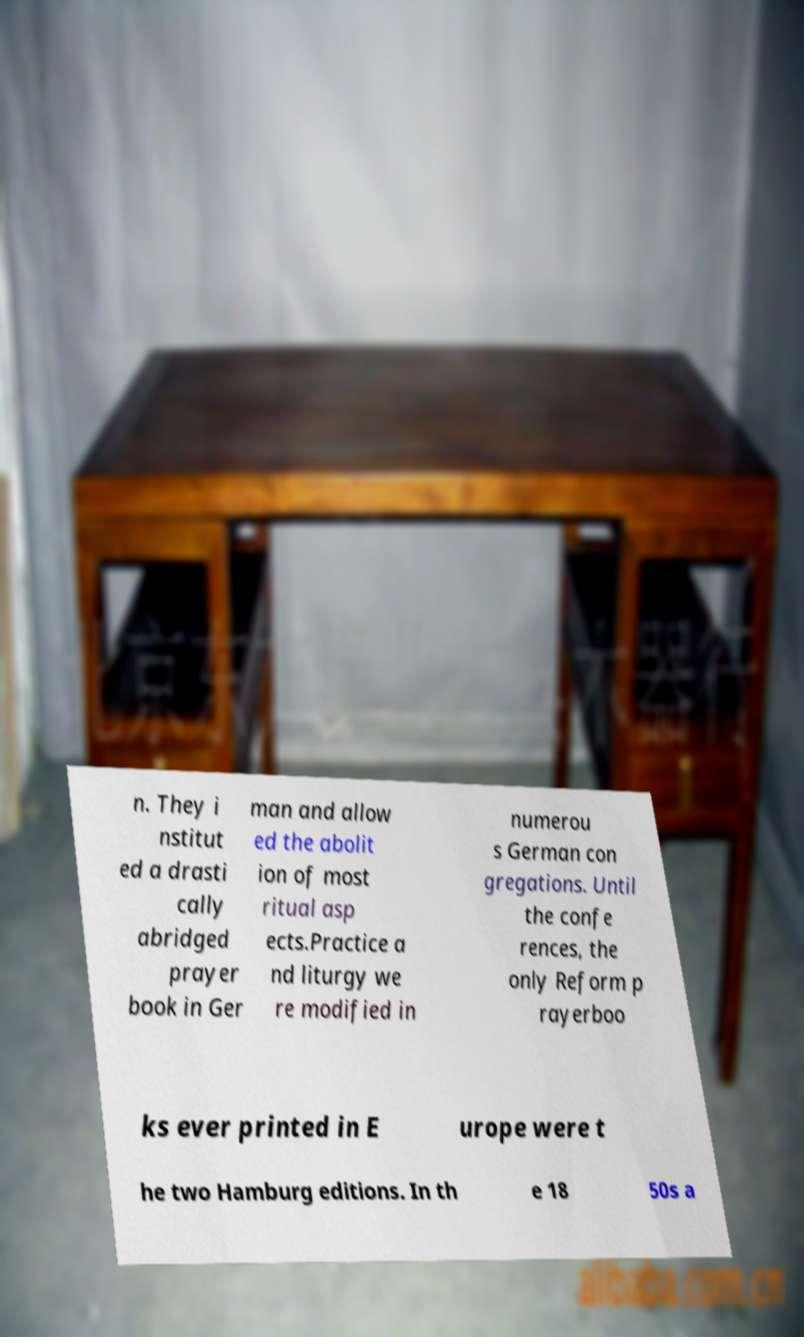Can you read and provide the text displayed in the image?This photo seems to have some interesting text. Can you extract and type it out for me? n. They i nstitut ed a drasti cally abridged prayer book in Ger man and allow ed the abolit ion of most ritual asp ects.Practice a nd liturgy we re modified in numerou s German con gregations. Until the confe rences, the only Reform p rayerboo ks ever printed in E urope were t he two Hamburg editions. In th e 18 50s a 